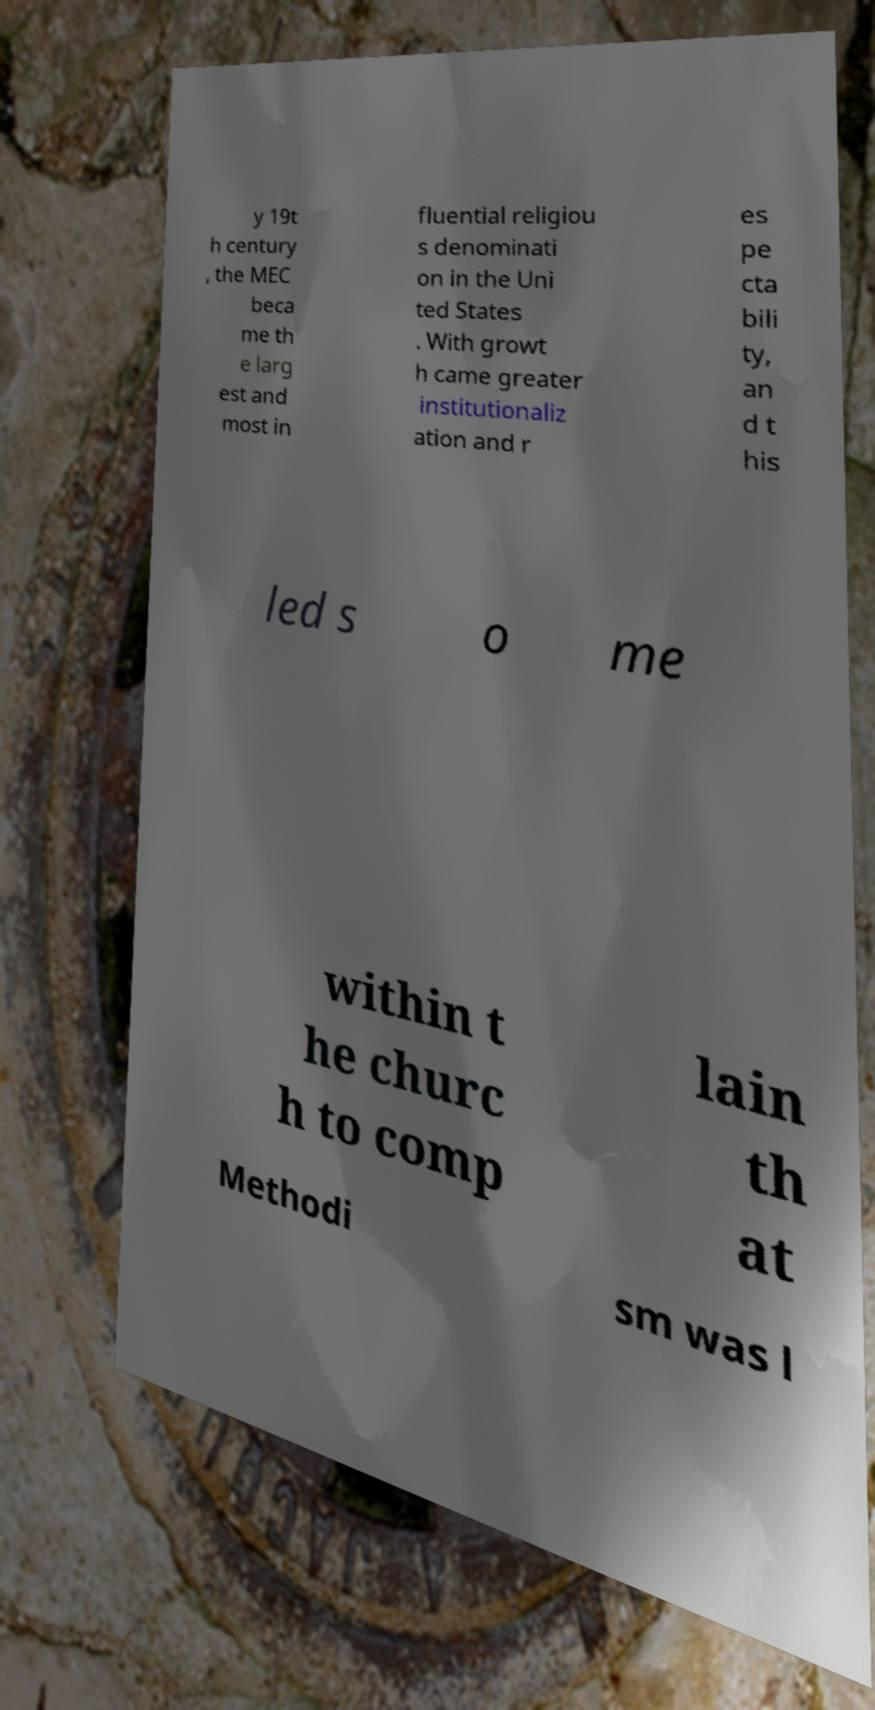I need the written content from this picture converted into text. Can you do that? y 19t h century , the MEC beca me th e larg est and most in fluential religiou s denominati on in the Uni ted States . With growt h came greater institutionaliz ation and r es pe cta bili ty, an d t his led s o me within t he churc h to comp lain th at Methodi sm was l 